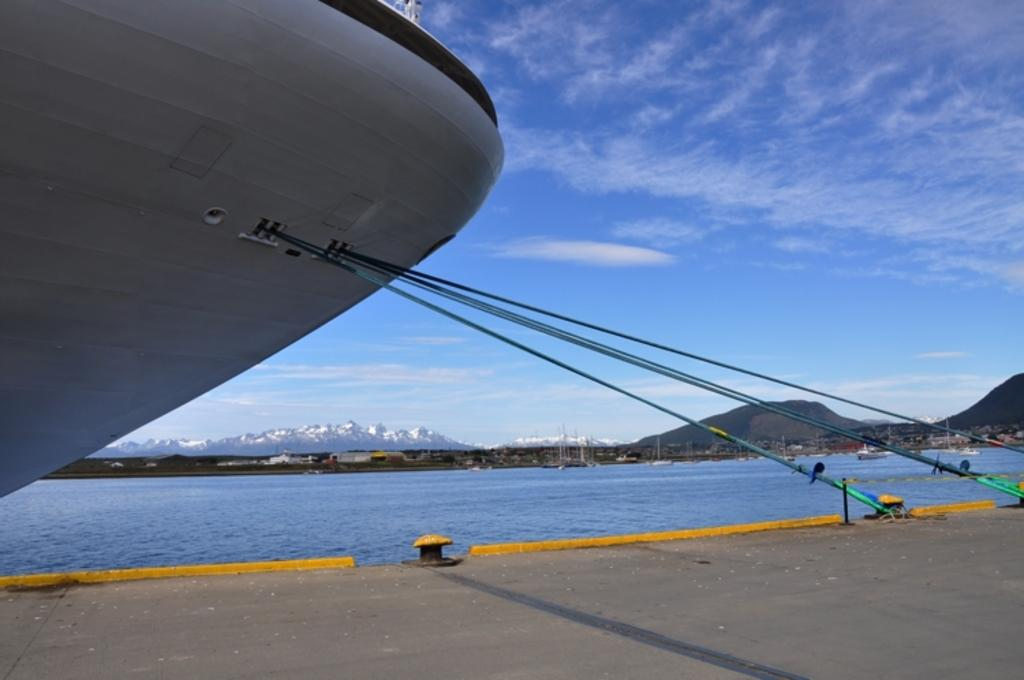What is located on the left side of the image? There is a ship on the left side of the image. Where is the ship situated? The ship is in a lake. What else can be seen in the image besides the ship? There is a road and hills visible in the background of the image. What is visible in the sky in the image? The sky is visible in the image, and clouds are present. How does the ship digest its fuel in the image? Ships do not have a digestive system, so the concept of digestion is not applicable to the ship in the image. 